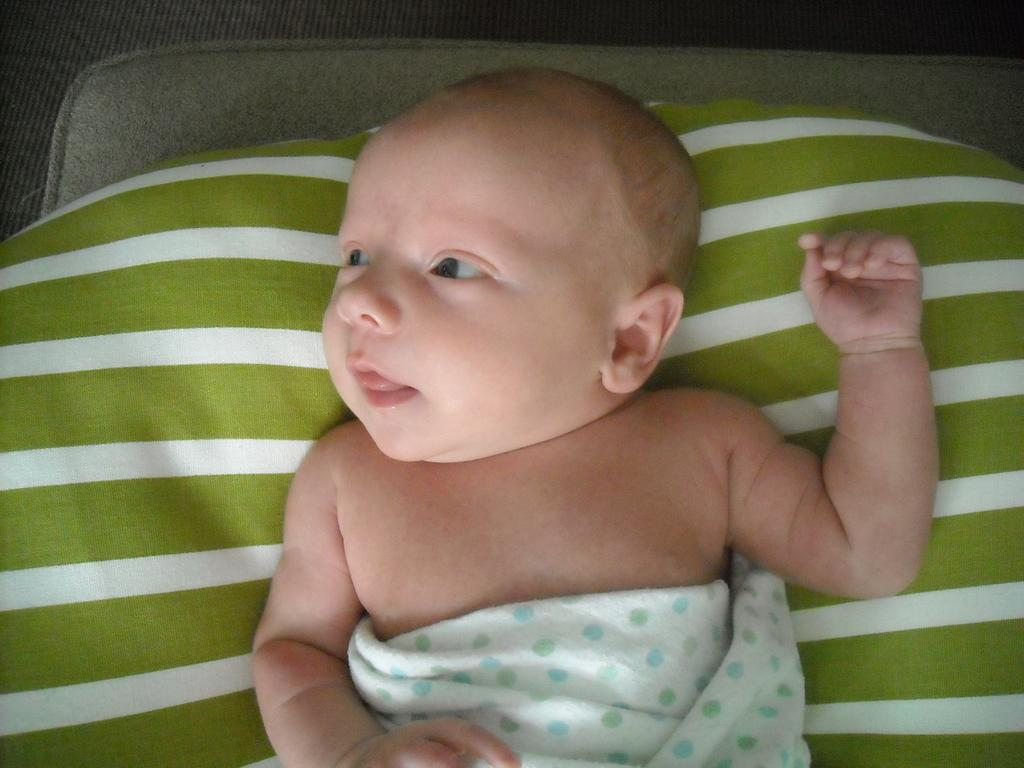What is the main subject of the image? There is a baby in the image. What else can be seen in the image besides the baby? There are clothes and a grey object in the image. What type of breakfast is the baby eating in the image? There is no indication in the image that the baby is eating breakfast, so it cannot be determined from the picture. 